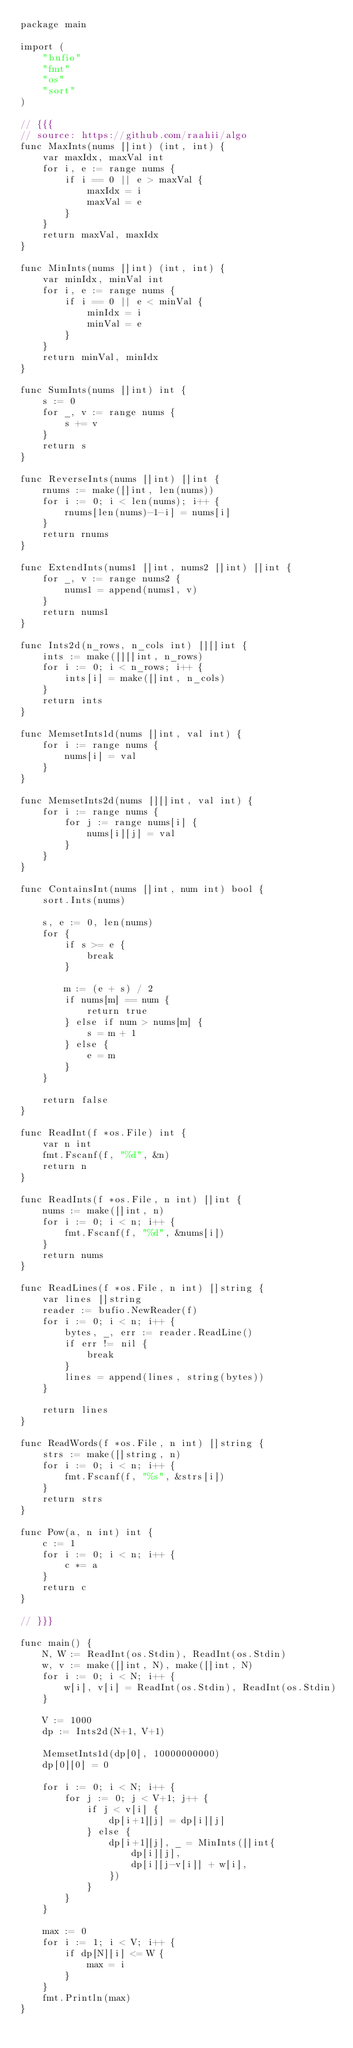Convert code to text. <code><loc_0><loc_0><loc_500><loc_500><_Go_>package main

import (
	"bufio"
	"fmt"
	"os"
	"sort"
)

// {{{
// source: https://github.com/raahii/algo
func MaxInts(nums []int) (int, int) {
	var maxIdx, maxVal int
	for i, e := range nums {
		if i == 0 || e > maxVal {
			maxIdx = i
			maxVal = e
		}
	}
	return maxVal, maxIdx
}

func MinInts(nums []int) (int, int) {
	var minIdx, minVal int
	for i, e := range nums {
		if i == 0 || e < minVal {
			minIdx = i
			minVal = e
		}
	}
	return minVal, minIdx
}

func SumInts(nums []int) int {
	s := 0
	for _, v := range nums {
		s += v
	}
	return s
}

func ReverseInts(nums []int) []int {
	rnums := make([]int, len(nums))
	for i := 0; i < len(nums); i++ {
		rnums[len(nums)-1-i] = nums[i]
	}
	return rnums
}

func ExtendInts(nums1 []int, nums2 []int) []int {
	for _, v := range nums2 {
		nums1 = append(nums1, v)
	}
	return nums1
}

func Ints2d(n_rows, n_cols int) [][]int {
	ints := make([][]int, n_rows)
	for i := 0; i < n_rows; i++ {
		ints[i] = make([]int, n_cols)
	}
	return ints
}

func MemsetInts1d(nums []int, val int) {
	for i := range nums {
		nums[i] = val
	}
}

func MemsetInts2d(nums [][]int, val int) {
	for i := range nums {
		for j := range nums[i] {
			nums[i][j] = val
		}
	}
}

func ContainsInt(nums []int, num int) bool {
	sort.Ints(nums)

	s, e := 0, len(nums)
	for {
		if s >= e {
			break
		}

		m := (e + s) / 2
		if nums[m] == num {
			return true
		} else if num > nums[m] {
			s = m + 1
		} else {
			e = m
		}
	}

	return false
}

func ReadInt(f *os.File) int {
	var n int
	fmt.Fscanf(f, "%d", &n)
	return n
}

func ReadInts(f *os.File, n int) []int {
	nums := make([]int, n)
	for i := 0; i < n; i++ {
		fmt.Fscanf(f, "%d", &nums[i])
	}
	return nums
}

func ReadLines(f *os.File, n int) []string {
	var lines []string
	reader := bufio.NewReader(f)
	for i := 0; i < n; i++ {
		bytes, _, err := reader.ReadLine()
		if err != nil {
			break
		}
		lines = append(lines, string(bytes))
	}

	return lines
}

func ReadWords(f *os.File, n int) []string {
	strs := make([]string, n)
	for i := 0; i < n; i++ {
		fmt.Fscanf(f, "%s", &strs[i])
	}
	return strs
}

func Pow(a, n int) int {
	c := 1
	for i := 0; i < n; i++ {
		c *= a
	}
	return c
}

// }}}

func main() {
	N, W := ReadInt(os.Stdin), ReadInt(os.Stdin)
	w, v := make([]int, N), make([]int, N)
	for i := 0; i < N; i++ {
		w[i], v[i] = ReadInt(os.Stdin), ReadInt(os.Stdin)
	}

	V := 1000
	dp := Ints2d(N+1, V+1)

	MemsetInts1d(dp[0], 10000000000)
	dp[0][0] = 0

	for i := 0; i < N; i++ {
		for j := 0; j < V+1; j++ {
			if j < v[i] {
				dp[i+1][j] = dp[i][j]
			} else {
				dp[i+1][j], _ = MinInts([]int{
					dp[i][j],
					dp[i][j-v[i]] + w[i],
				})
			}
		}
	}

	max := 0
	for i := 1; i < V; i++ {
		if dp[N][i] <= W {
			max = i
		}
	}
	fmt.Println(max)
}</code> 